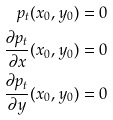<formula> <loc_0><loc_0><loc_500><loc_500>p _ { t } ( x _ { 0 } , y _ { 0 } ) = 0 \\ \frac { \partial p _ { t } } { \partial x } ( x _ { 0 } , y _ { 0 } ) = 0 \\ \frac { \partial p _ { t } } { \partial y } ( x _ { 0 } , y _ { 0 } ) = 0</formula> 